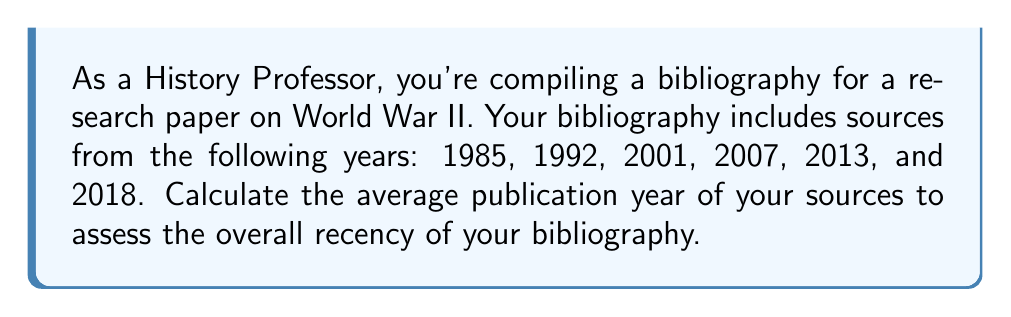Teach me how to tackle this problem. To calculate the average publication year, we need to follow these steps:

1. Sum up all the publication years:
   $1985 + 1992 + 2001 + 2007 + 2013 + 2018 = 12016$

2. Count the total number of sources:
   There are 6 sources in total.

3. Calculate the average by dividing the sum by the number of sources:
   $$\text{Average} = \frac{\text{Sum of years}}{\text{Number of sources}} = \frac{12016}{6}$$

4. Perform the division:
   $$\frac{12016}{6} = 2002.6666...$$ 

5. Round to the nearest whole year:
   $2002.6666...$ rounds to 2003

Therefore, the average publication year of your bibliography is 2003.
Answer: 2003 